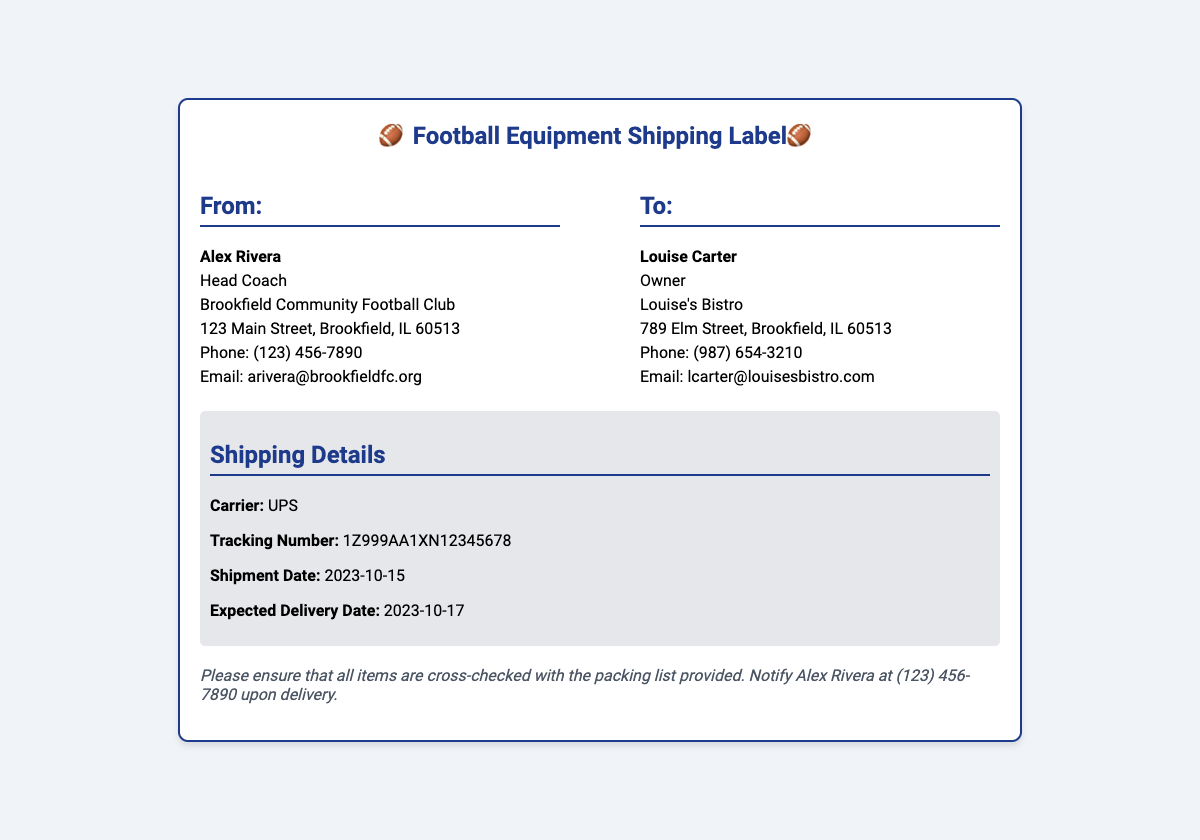What is the name of the sender? The sender is identified as Alex Rivera, who is the Head Coach of the Brookfield Community Football Club.
Answer: Alex Rivera What is the tracking number? The tracking number for the shipment is specifically listed in the document as 1Z999AA1XN12345678.
Answer: 1Z999AA1XN12345678 What is the expected delivery date? The document states the expected delivery date to be 2023-10-17.
Answer: 2023-10-17 Who is the recipient of the equipment? The recipient is named as Louise Carter, who is the owner of Louise's Bistro.
Answer: Louise Carter What is the carrier for the shipment? The document specifies that UPS is the carrier responsible for the shipment.
Answer: UPS What date was the shipment processed? The shipment date mentioned in the document is 2023-10-15.
Answer: 2023-10-15 What should be done upon delivery? The document instructs to notify Alex Rivera at (123) 456-7890 upon delivery.
Answer: Notify Alex Rivera What type of equipment is being shipped? The document mentions that the shipment includes football equipment, specifically uniforms and gear.
Answer: Football equipment What is the address of the sender? The sender's address is provided as 123 Main Street, Brookfield, IL 60513.
Answer: 123 Main Street, Brookfield, IL 60513 